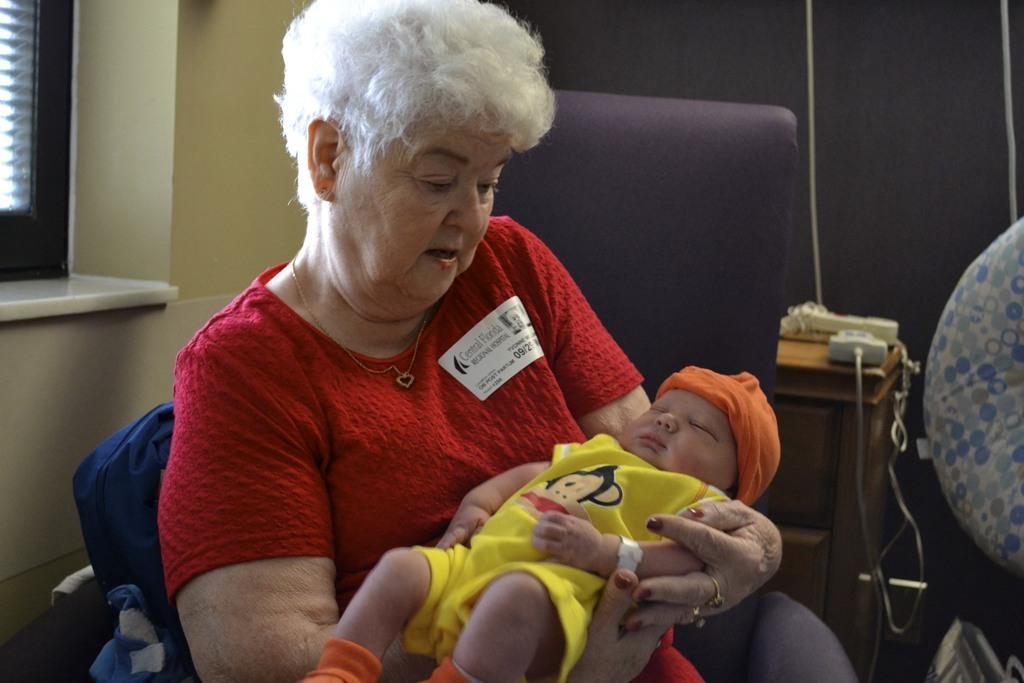In one or two sentences, can you explain what this image depicts? In the image there is a woman sitting and holding the baby in her hands. Behind her chair there is a table with a few items on it. On the left side of the image there is a window on the wall. And on the right side of the image there is a cloth. And there is a black curtain in the background. 